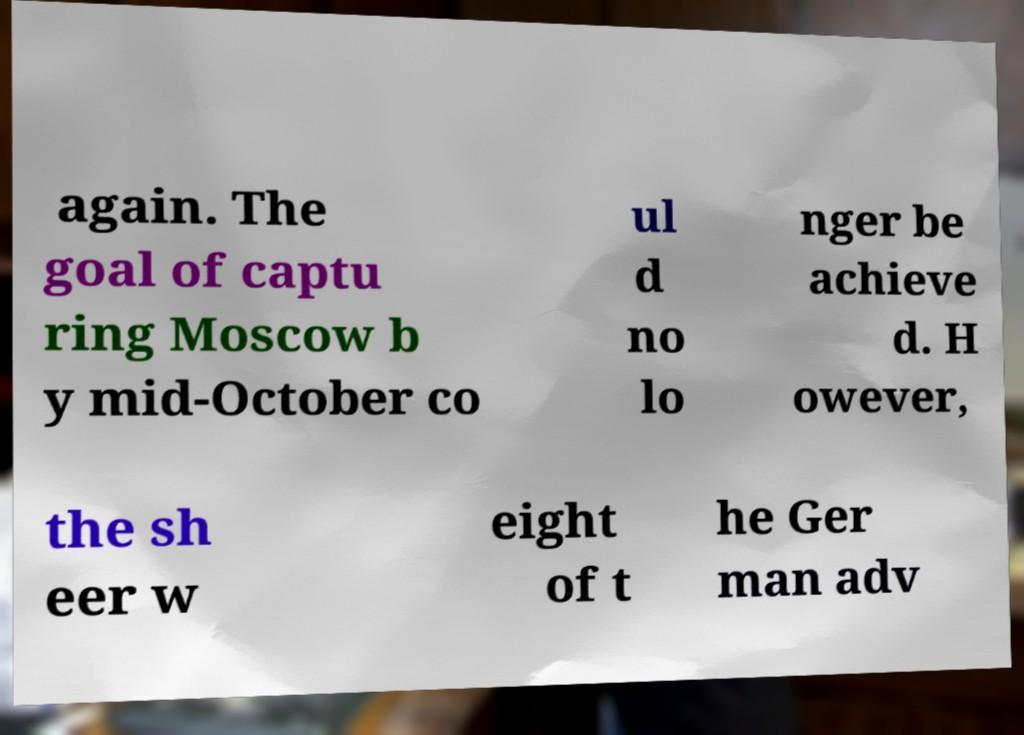Please identify and transcribe the text found in this image. again. The goal of captu ring Moscow b y mid-October co ul d no lo nger be achieve d. H owever, the sh eer w eight of t he Ger man adv 